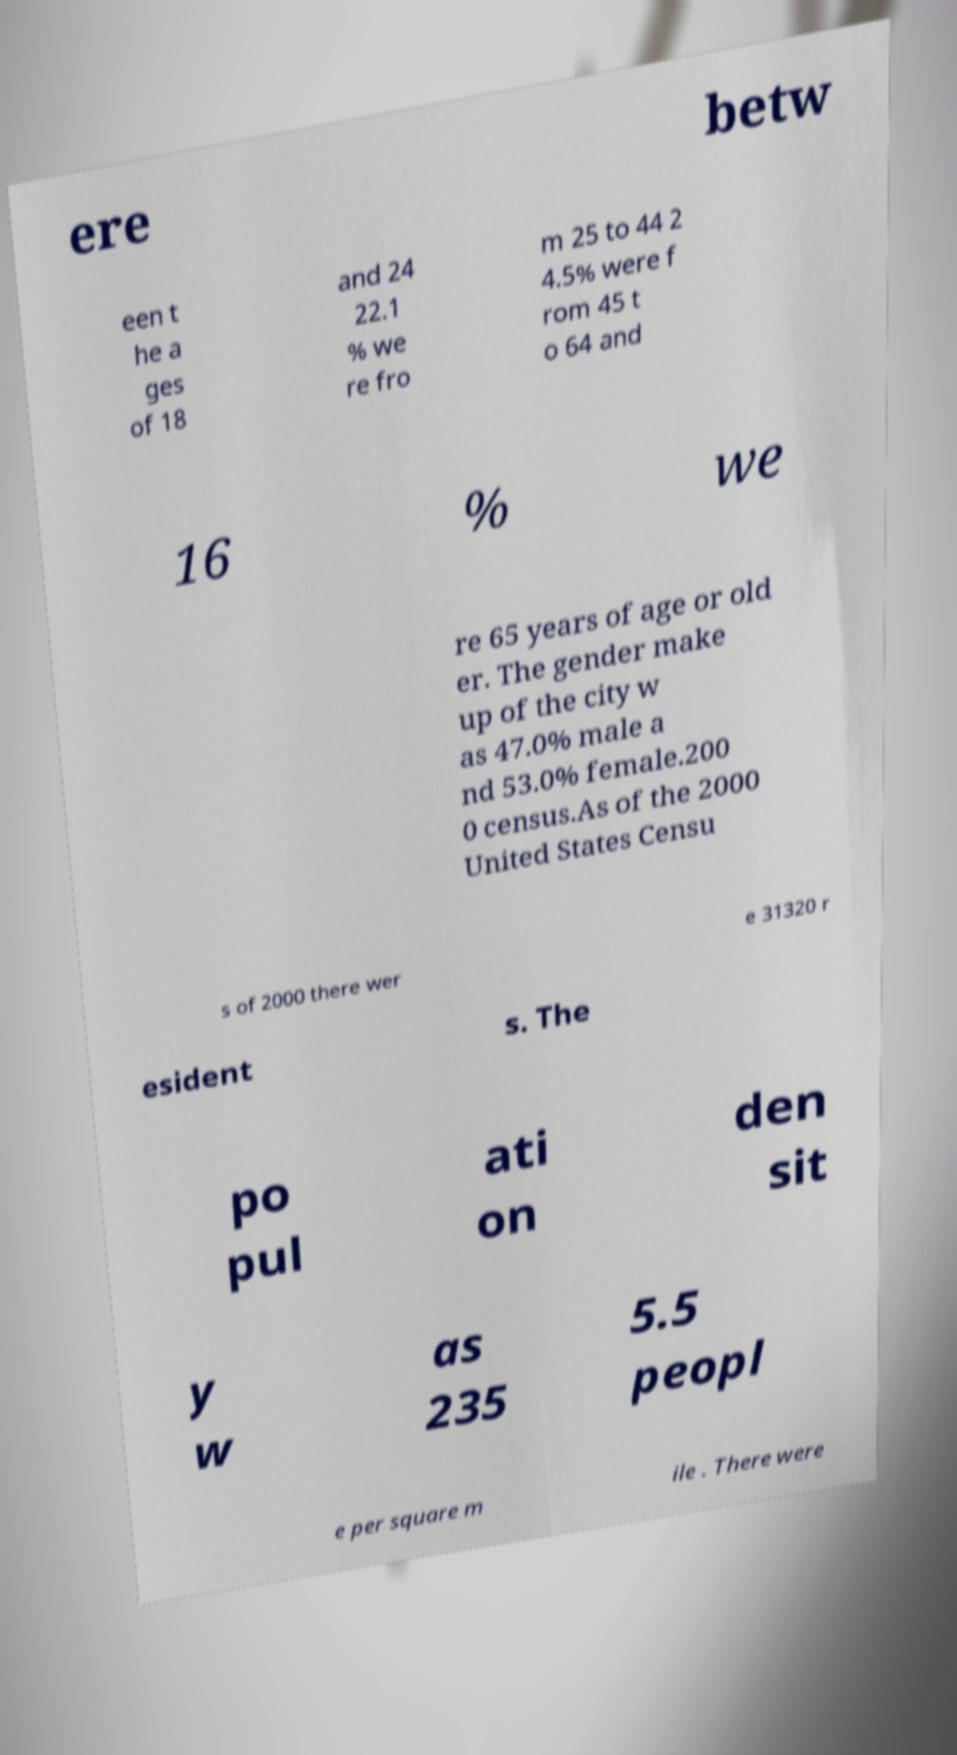There's text embedded in this image that I need extracted. Can you transcribe it verbatim? ere betw een t he a ges of 18 and 24 22.1 % we re fro m 25 to 44 2 4.5% were f rom 45 t o 64 and 16 % we re 65 years of age or old er. The gender make up of the city w as 47.0% male a nd 53.0% female.200 0 census.As of the 2000 United States Censu s of 2000 there wer e 31320 r esident s. The po pul ati on den sit y w as 235 5.5 peopl e per square m ile . There were 